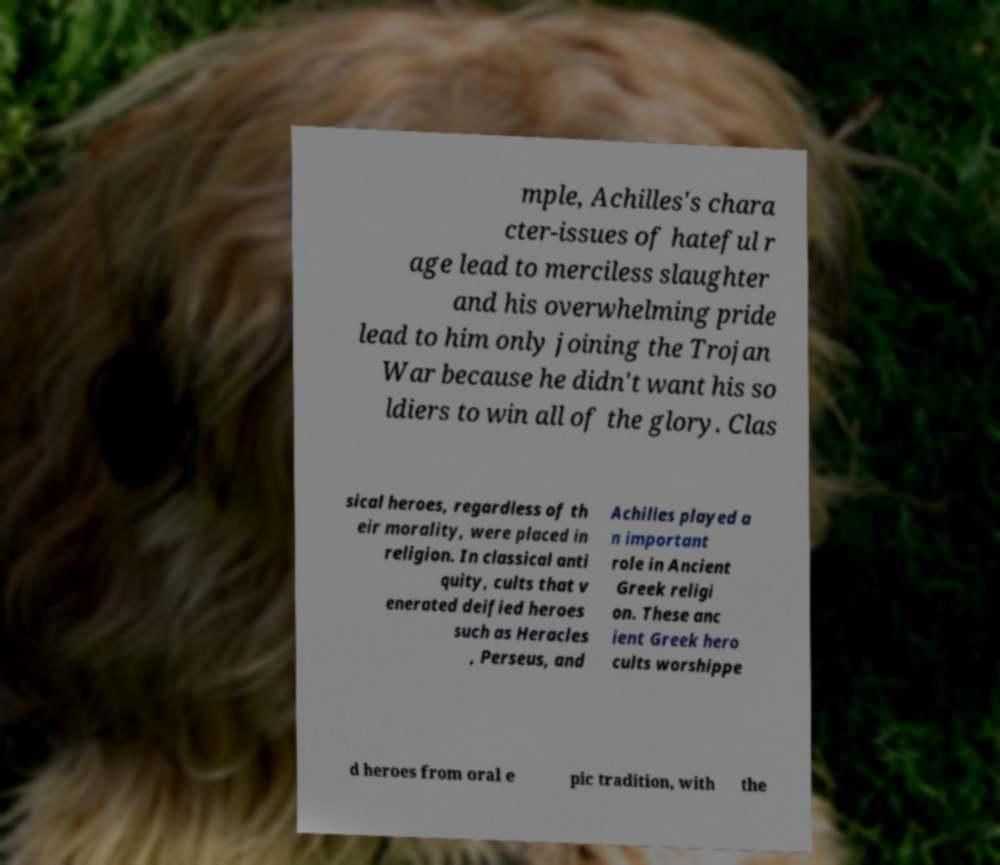For documentation purposes, I need the text within this image transcribed. Could you provide that? mple, Achilles's chara cter-issues of hateful r age lead to merciless slaughter and his overwhelming pride lead to him only joining the Trojan War because he didn't want his so ldiers to win all of the glory. Clas sical heroes, regardless of th eir morality, were placed in religion. In classical anti quity, cults that v enerated deified heroes such as Heracles , Perseus, and Achilles played a n important role in Ancient Greek religi on. These anc ient Greek hero cults worshippe d heroes from oral e pic tradition, with the 